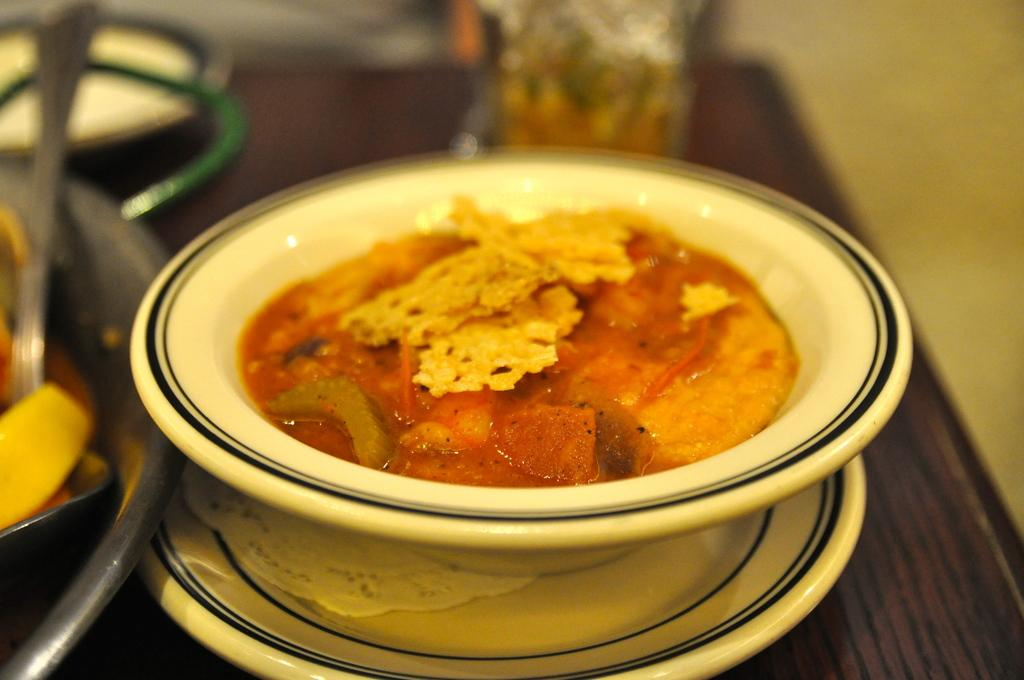What is in the bowls that are visible in the image? There are bowls with food in the image. What else can be seen on the table besides the bowls? There are other objects on the table. What is visible in the background of the image? There is a wall visible in the image. What type of apparel is being worn by the bell in the image? There is no bell present in the image, and therefore no apparel can be associated with it. 